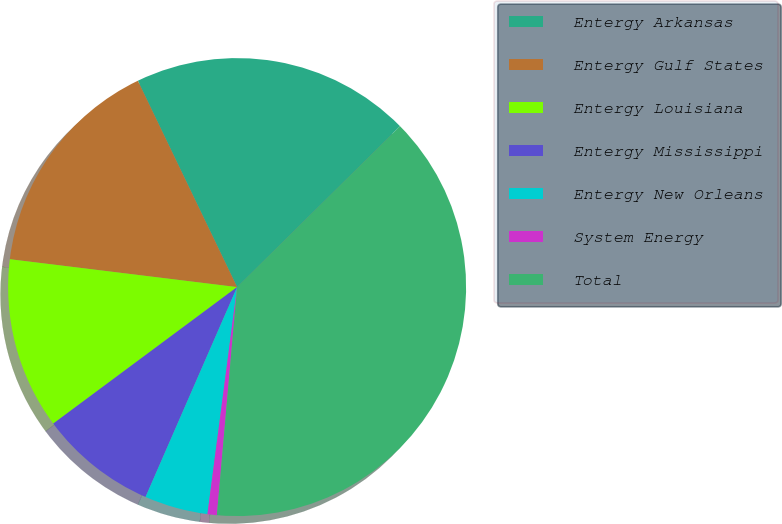<chart> <loc_0><loc_0><loc_500><loc_500><pie_chart><fcel>Entergy Arkansas<fcel>Entergy Gulf States<fcel>Entergy Louisiana<fcel>Entergy Mississippi<fcel>Entergy New Orleans<fcel>System Energy<fcel>Total<nl><fcel>19.74%<fcel>15.92%<fcel>12.11%<fcel>8.29%<fcel>4.48%<fcel>0.66%<fcel>38.81%<nl></chart> 